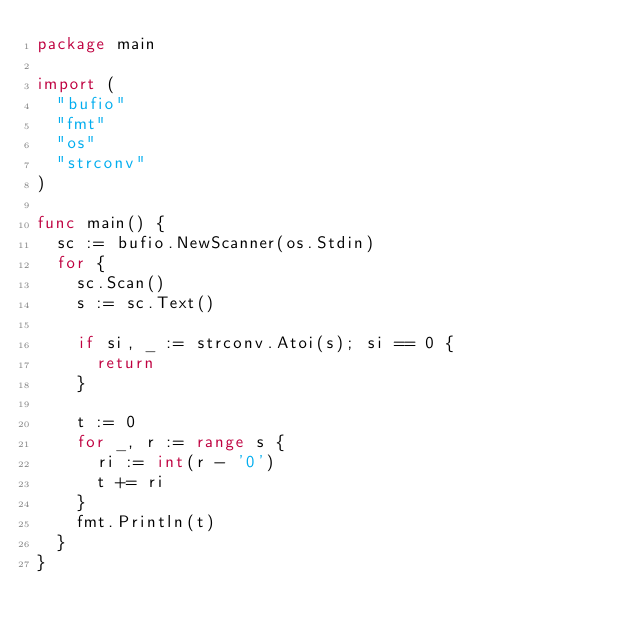Convert code to text. <code><loc_0><loc_0><loc_500><loc_500><_Go_>package main

import (
	"bufio"
	"fmt"
	"os"
	"strconv"
)

func main() {
	sc := bufio.NewScanner(os.Stdin)
	for {
		sc.Scan()
		s := sc.Text()

		if si, _ := strconv.Atoi(s); si == 0 {
			return
		}

		t := 0
		for _, r := range s {
			ri := int(r - '0')
			t += ri
		}
		fmt.Println(t)
	}
}

</code> 